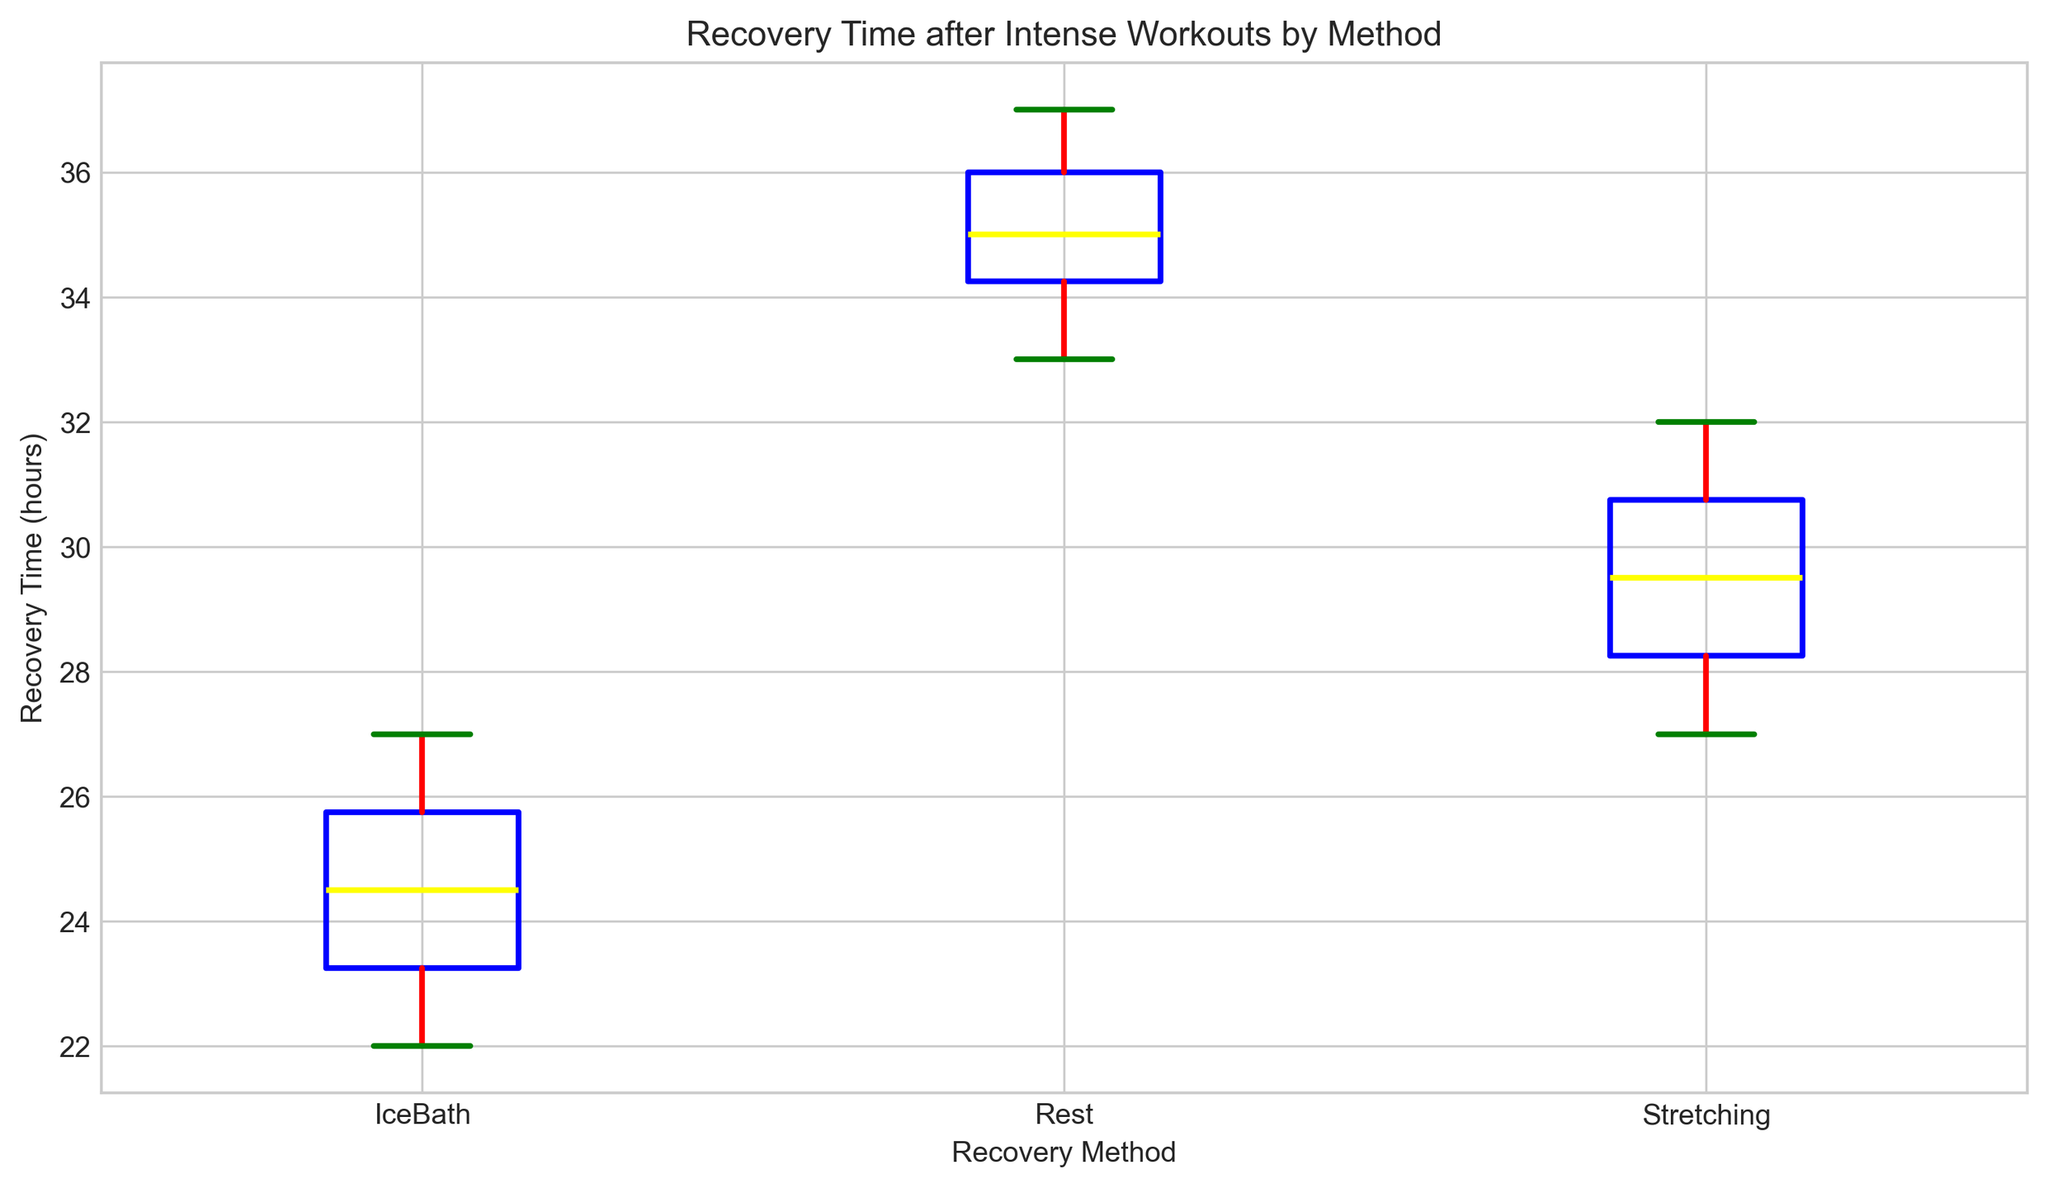What's the median recovery time for ice baths? To find the median recovery time for ice baths, you need to arrange the recovery times in numerical order: 22, 23, 23, 24, 24, 25, 25, 26, 26, 27. Since there are 10 data points, the median is the average of the 5th and 6th values, which are both 24.5.
Answer: 24 Which recovery method has the greatest variability in recovery time? Variability in recovery time can be seen through the length of the box and whiskers. The "Rest" method shows the largest box and longest whiskers, indicating higher variability.
Answer: Rest What is the interquartile range (IQR) for stretching? To find the IQR, you need to identify the first quartile (Q1) and the third quartile (Q3) and subtract Q1 from Q3. For stretching, Q1 is 28, and Q3 is 30, so the IQR is 30 - 28.
Answer: 2 Which recovery method has the shortest median recovery time? By examining the median line inside each box, you can see that IceBath has the lowest median recovery time compared to other methods.
Answer: IceBath Are there any outliers in the recovery times for any method? Outliers are identified as points beyond the whiskers. In this box plot, there are no individual points beyond the whiskers for any method, thus no outliers.
Answer: No What is the difference between the maximum recovery times of ice baths and rest? The maximum recovery time for ice baths is 27 hours, and for rest, it's 37 hours. Subtract 27 from 37 to find the difference.
Answer: 10 Which method's recovery time range is more compact: ice baths or stretching? To determine compactness, compare the range (maximum - minimum) for each method. IceBath has a range of (27-22) = 5, and Stretching has a range of (32-27) = 5. Both methods have the same compactness.
Answer: Equal What color are the whiskers in the box plot? By examining the visual attributes of the plot, the whiskers are colored red.
Answer: Red Which recovery method has the highest minimum recovery time? The lower end of each box indicates the minimum recovery time. Rest has the highest minimum recovery time at 33 hours.
Answer: Rest What is the difference between the first quartile (Q1) and third quartile (Q3) for ice baths? The first quartile (Q1) for ice baths is 23, and the third quartile (Q3) is 26. Subtract Q1 from Q3 to find the difference, which is 26 - 23.
Answer: 3 